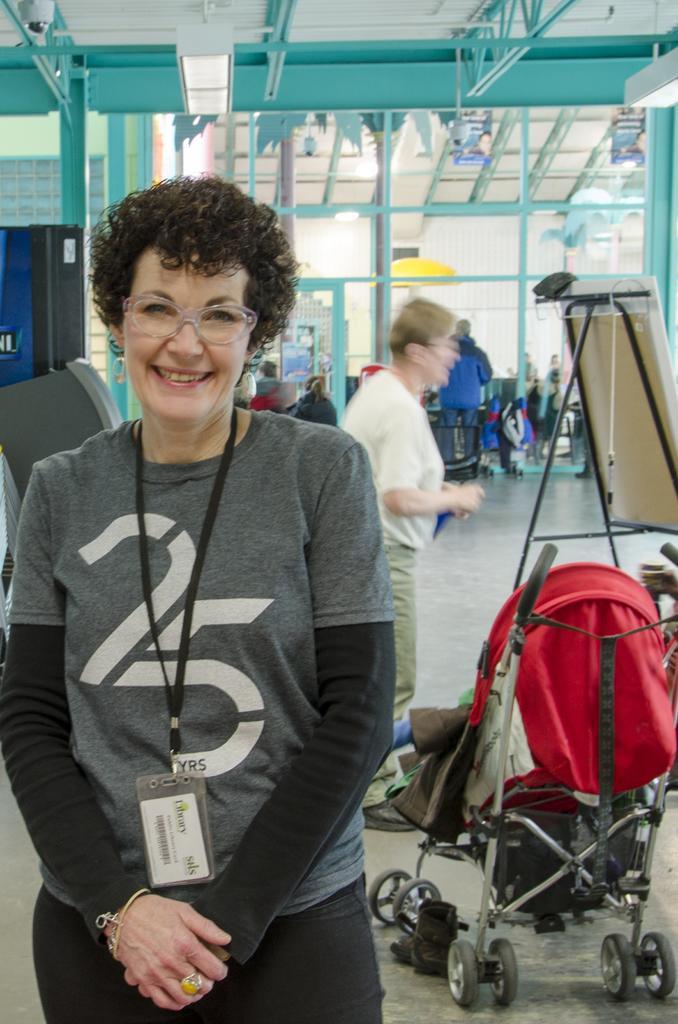Could you give a brief overview of what you see in this image? In the foreground of the picture there is a woman smiling, behind her there are cart, board and a person standing. In the background there are glass windows, doors, people and iron frames. At the top there are lights. 